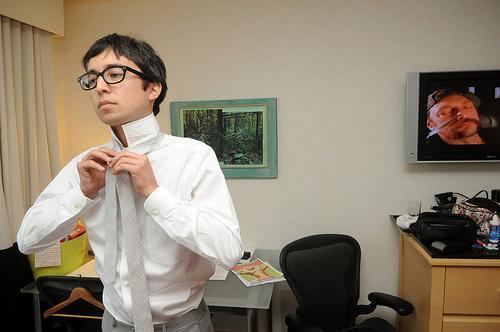How many men are there?
Give a very brief answer. 1. 